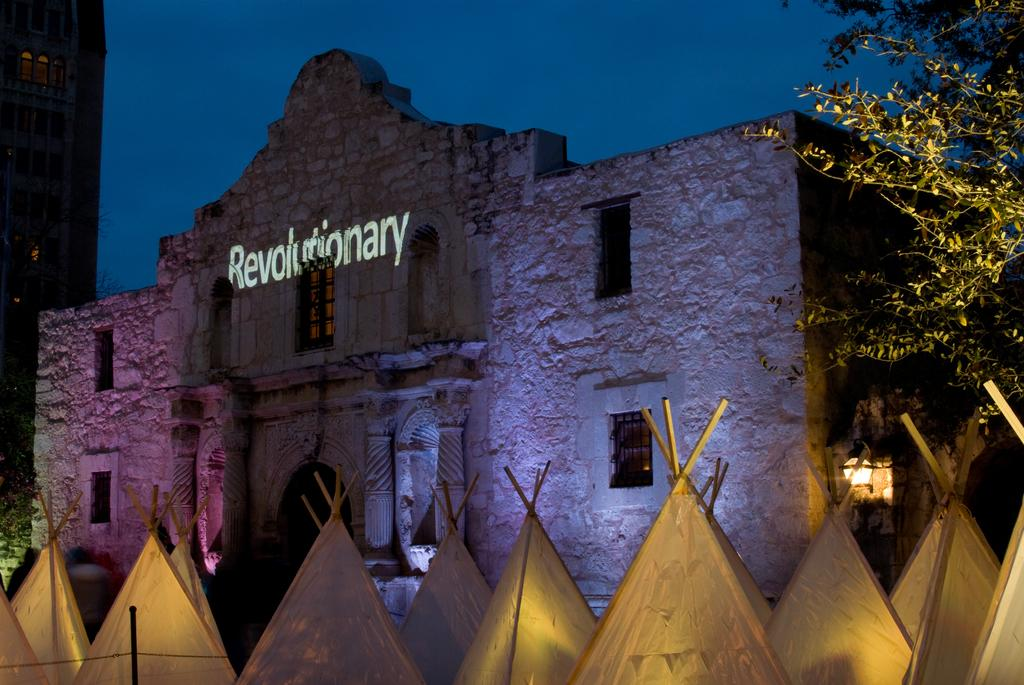Provide a one-sentence caption for the provided image. An old brick building replica of the Alamo is lit up with the word Revolutionary on it. 